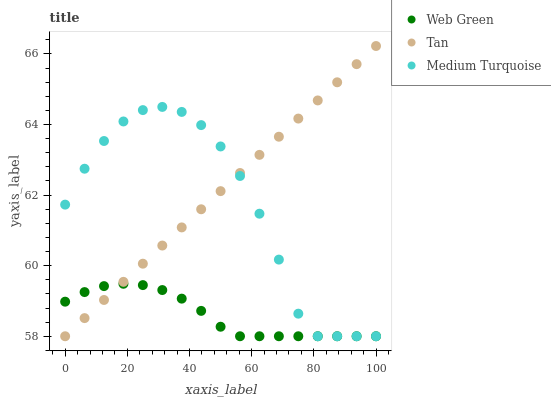Does Web Green have the minimum area under the curve?
Answer yes or no. Yes. Does Tan have the maximum area under the curve?
Answer yes or no. Yes. Does Medium Turquoise have the minimum area under the curve?
Answer yes or no. No. Does Medium Turquoise have the maximum area under the curve?
Answer yes or no. No. Is Tan the smoothest?
Answer yes or no. Yes. Is Medium Turquoise the roughest?
Answer yes or no. Yes. Is Web Green the smoothest?
Answer yes or no. No. Is Web Green the roughest?
Answer yes or no. No. Does Tan have the lowest value?
Answer yes or no. Yes. Does Tan have the highest value?
Answer yes or no. Yes. Does Medium Turquoise have the highest value?
Answer yes or no. No. Does Web Green intersect Tan?
Answer yes or no. Yes. Is Web Green less than Tan?
Answer yes or no. No. Is Web Green greater than Tan?
Answer yes or no. No. 